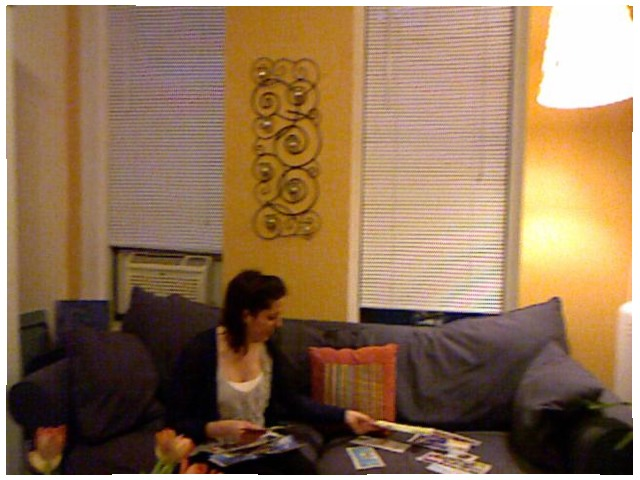<image>
Is there a paper next to the couch? No. The paper is not positioned next to the couch. They are located in different areas of the scene. Is the window behind the sofa? Yes. From this viewpoint, the window is positioned behind the sofa, with the sofa partially or fully occluding the window. Is the window behind the sofa? Yes. From this viewpoint, the window is positioned behind the sofa, with the sofa partially or fully occluding the window. Is the cushion behind the flower? No. The cushion is not behind the flower. From this viewpoint, the cushion appears to be positioned elsewhere in the scene. 